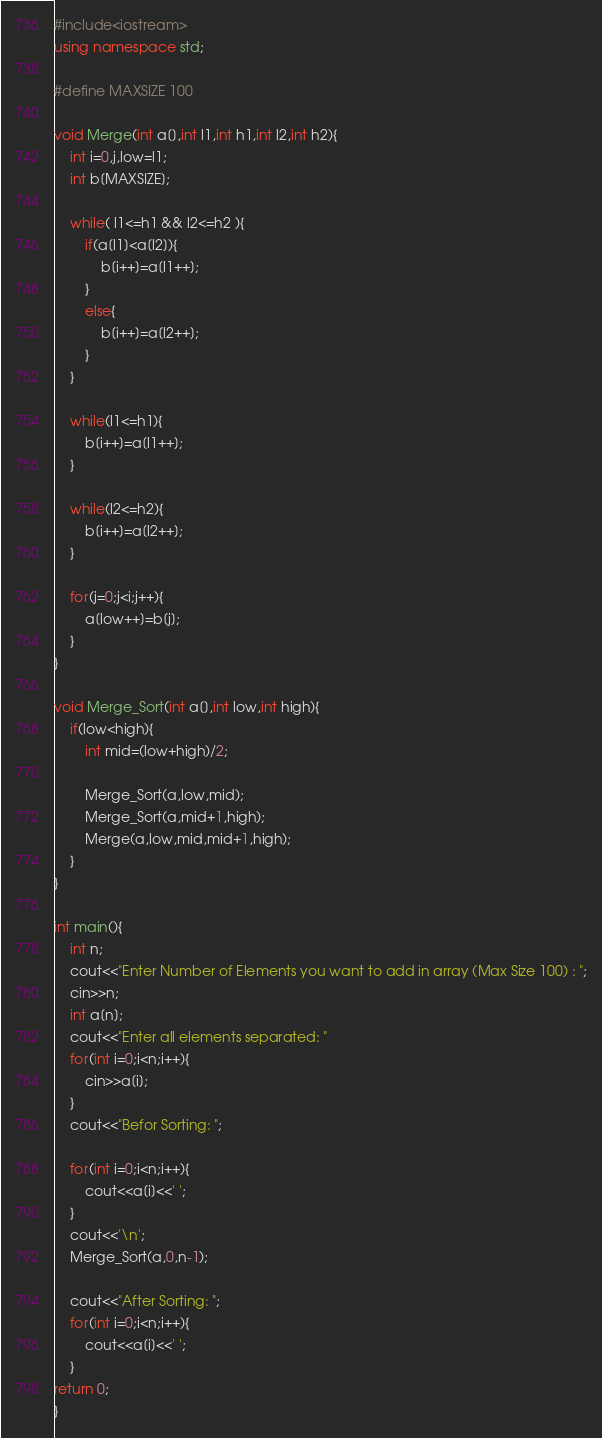Convert code to text. <code><loc_0><loc_0><loc_500><loc_500><_C++_>#include<iostream>
using namespace std;

#define MAXSIZE 100

void Merge(int a[],int l1,int h1,int l2,int h2){
    int i=0,j,low=l1;
    int b[MAXSIZE];

    while( l1<=h1 && l2<=h2 ){
        if(a[l1]<a[l2]){
            b[i++]=a[l1++];
        }
        else{
            b[i++]=a[l2++];
        }
    }

    while(l1<=h1){
        b[i++]=a[l1++];
    }

    while(l2<=h2){
        b[i++]=a[l2++];
    }

    for(j=0;j<i;j++){
        a[low++]=b[j];
    }
}

void Merge_Sort(int a[],int low,int high){
    if(low<high){
        int mid=(low+high)/2;

        Merge_Sort(a,low,mid);
        Merge_Sort(a,mid+1,high);
        Merge(a,low,mid,mid+1,high);
    }
}

int main(){
    int n;
    cout<<"Enter Number of Elements you want to add in array (Max Size 100) : ";
    cin>>n;
    int a[n];
    cout<<"Enter all elements separated: "
    for(int i=0;i<n;i++){
        cin>>a[i];
    }
    cout<<"Befor Sorting: ";

    for(int i=0;i<n;i++){
        cout<<a[i]<<' ';
    }
    cout<<'\n';
    Merge_Sort(a,0,n-1);

    cout<<"After Sorting: ";
    for(int i=0;i<n;i++){
        cout<<a[i]<<' ';
    }
return 0;
}
</code> 